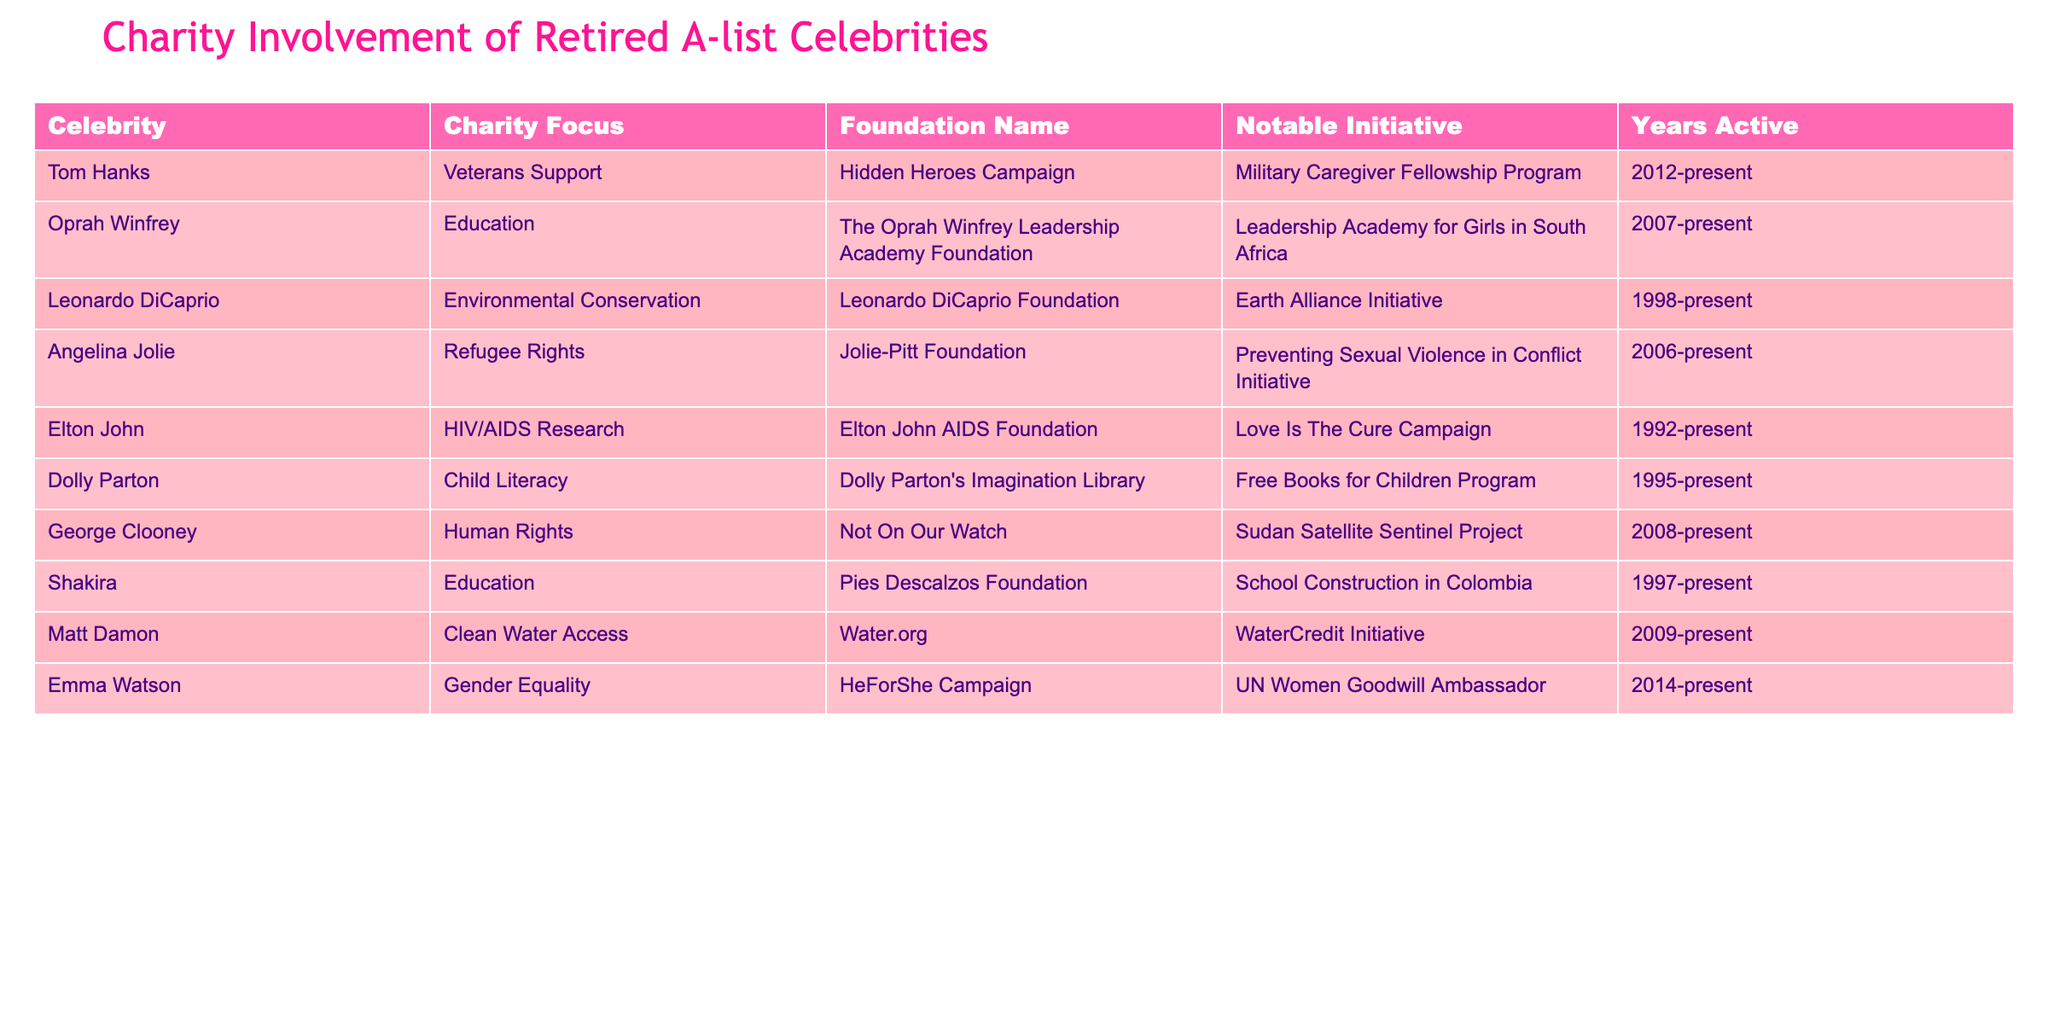What is the charity focus of Tom Hanks? The table lists "Veterans Support" as Tom Hanks' charity focus.
Answer: Veterans Support How many years has Elton John been active in his charitable work? The table states that Elton John has been active since 1992 to the present. It's currently 2023, so that makes it 31 years of active involvement.
Answer: 31 years What notable initiative is associated with Angelina Jolie's foundation? According to the table, the notable initiative for Angelina Jolie's foundation is the "Preventing Sexual Violence in Conflict Initiative."
Answer: Preventing Sexual Violence in Conflict Initiative Is George Clooney involved in environmental conservation? The table indicates that George Clooney's charity focus is "Human Rights," not environmental conservation.
Answer: No Who is focused on child literacy, and what is their foundation called? Dolly Parton is focused on child literacy, and her foundation is called "Dolly Parton's Imagination Library."
Answer: Dolly Parton, Dolly Parton's Imagination Library Which recipient has a focus on gender equality and what is their notable initiative? Emma Watson focuses on gender equality and her notable initiative is the "UN Women Goodwill Ambassador."
Answer: Emma Watson, UN Women Goodwill Ambassador Which celebrity has the longest history of charitable work in years? The table shows Leonardo DiCaprio has been active since 1998, which is longer than the others listed. Today, it's 2023, thus making it 25 years.
Answer: Leonardo DiCaprio How many celebrities have education as their charity focus? The table lists two celebrities focusing on education: Oprah Winfrey and Shakira.
Answer: 2 celebrities Which celebrity has been involved in charity work for the shortest time from the listed data? The table shows that Emma Watson is active since 2014, making her involvement the shortest among the listed celebrities.
Answer: Emma Watson What is the total number of celebrities listed in the table? The table provides information on 10 celebrities in total.
Answer: 10 celebrities 